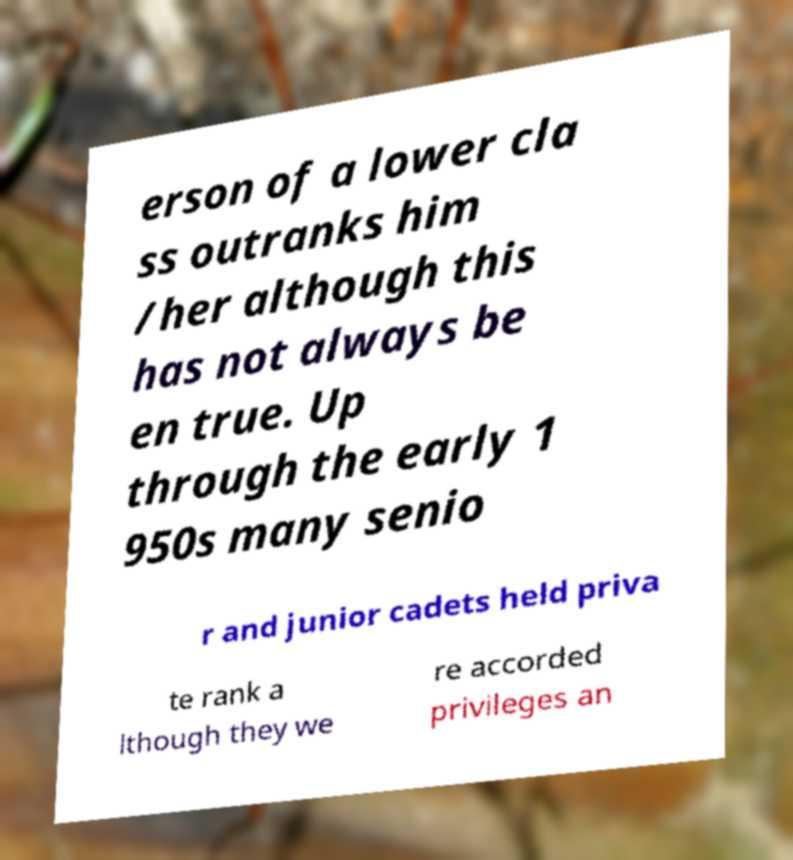For documentation purposes, I need the text within this image transcribed. Could you provide that? erson of a lower cla ss outranks him /her although this has not always be en true. Up through the early 1 950s many senio r and junior cadets held priva te rank a lthough they we re accorded privileges an 